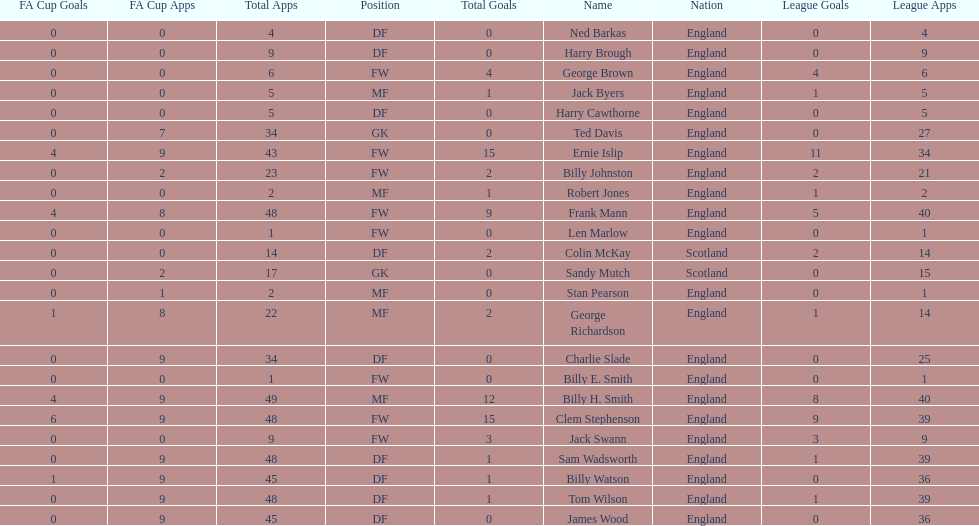Parse the full table. {'header': ['FA Cup Goals', 'FA Cup Apps', 'Total Apps', 'Position', 'Total Goals', 'Name', 'Nation', 'League Goals', 'League Apps'], 'rows': [['0', '0', '4', 'DF', '0', 'Ned Barkas', 'England', '0', '4'], ['0', '0', '9', 'DF', '0', 'Harry Brough', 'England', '0', '9'], ['0', '0', '6', 'FW', '4', 'George Brown', 'England', '4', '6'], ['0', '0', '5', 'MF', '1', 'Jack Byers', 'England', '1', '5'], ['0', '0', '5', 'DF', '0', 'Harry Cawthorne', 'England', '0', '5'], ['0', '7', '34', 'GK', '0', 'Ted Davis', 'England', '0', '27'], ['4', '9', '43', 'FW', '15', 'Ernie Islip', 'England', '11', '34'], ['0', '2', '23', 'FW', '2', 'Billy Johnston', 'England', '2', '21'], ['0', '0', '2', 'MF', '1', 'Robert Jones', 'England', '1', '2'], ['4', '8', '48', 'FW', '9', 'Frank Mann', 'England', '5', '40'], ['0', '0', '1', 'FW', '0', 'Len Marlow', 'England', '0', '1'], ['0', '0', '14', 'DF', '2', 'Colin McKay', 'Scotland', '2', '14'], ['0', '2', '17', 'GK', '0', 'Sandy Mutch', 'Scotland', '0', '15'], ['0', '1', '2', 'MF', '0', 'Stan Pearson', 'England', '0', '1'], ['1', '8', '22', 'MF', '2', 'George Richardson', 'England', '1', '14'], ['0', '9', '34', 'DF', '0', 'Charlie Slade', 'England', '0', '25'], ['0', '0', '1', 'FW', '0', 'Billy E. Smith', 'England', '0', '1'], ['4', '9', '49', 'MF', '12', 'Billy H. Smith', 'England', '8', '40'], ['6', '9', '48', 'FW', '15', 'Clem Stephenson', 'England', '9', '39'], ['0', '0', '9', 'FW', '3', 'Jack Swann', 'England', '3', '9'], ['0', '9', '48', 'DF', '1', 'Sam Wadsworth', 'England', '1', '39'], ['1', '9', '45', 'DF', '1', 'Billy Watson', 'England', '0', '36'], ['0', '9', '48', 'DF', '1', 'Tom Wilson', 'England', '1', '39'], ['0', '9', '45', 'DF', '0', 'James Wood', 'England', '0', '36']]} Which position is listed the least amount of times on this chart? GK. 